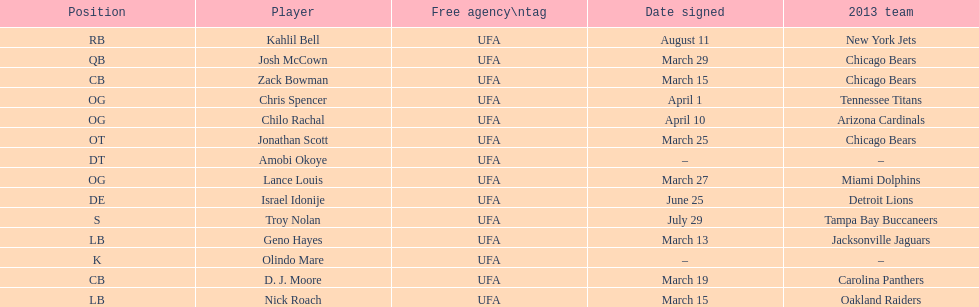How many players were signed in march? 7. 